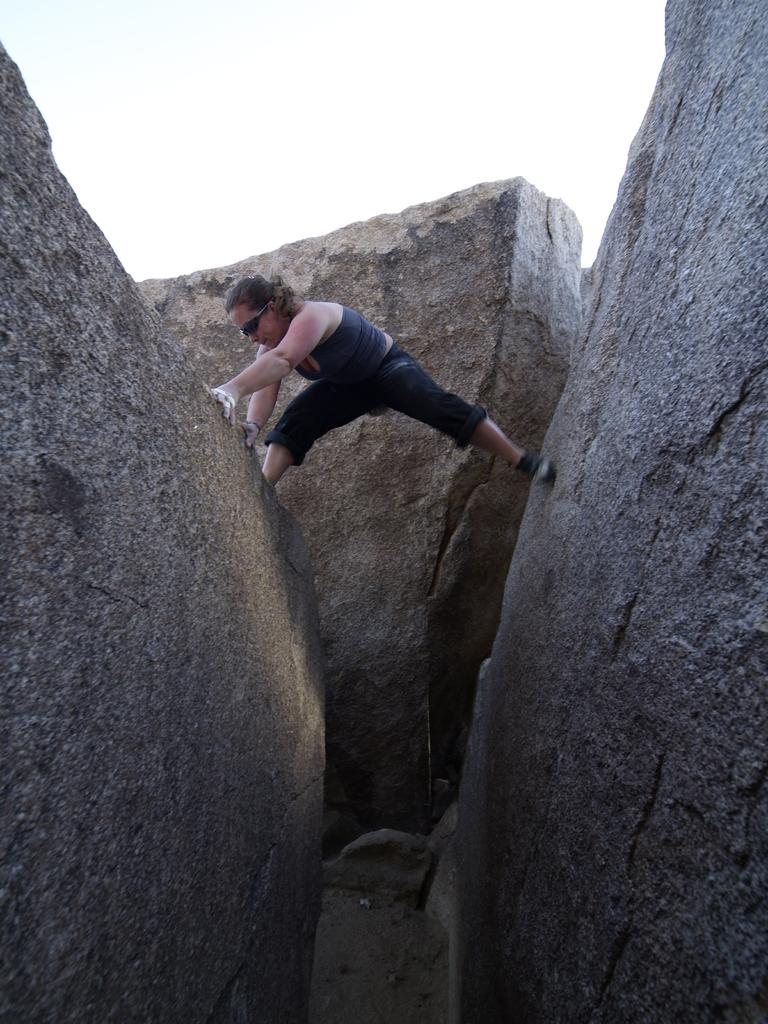What are the main objects in the image? There are two large rocks in the image. What is the person in the image doing? The person is standing with one leg on each rock. Are there any other rocks visible in the image? Yes, there is another rock visible behind the person. What can be seen in the background of the image? The sky is visible in the background of the image. What type of education is being discussed at the meeting in the image? There is no meeting or discussion of education present in the image. What is the mass of the rocks in the image? The mass of the rocks cannot be determined from the image alone. 